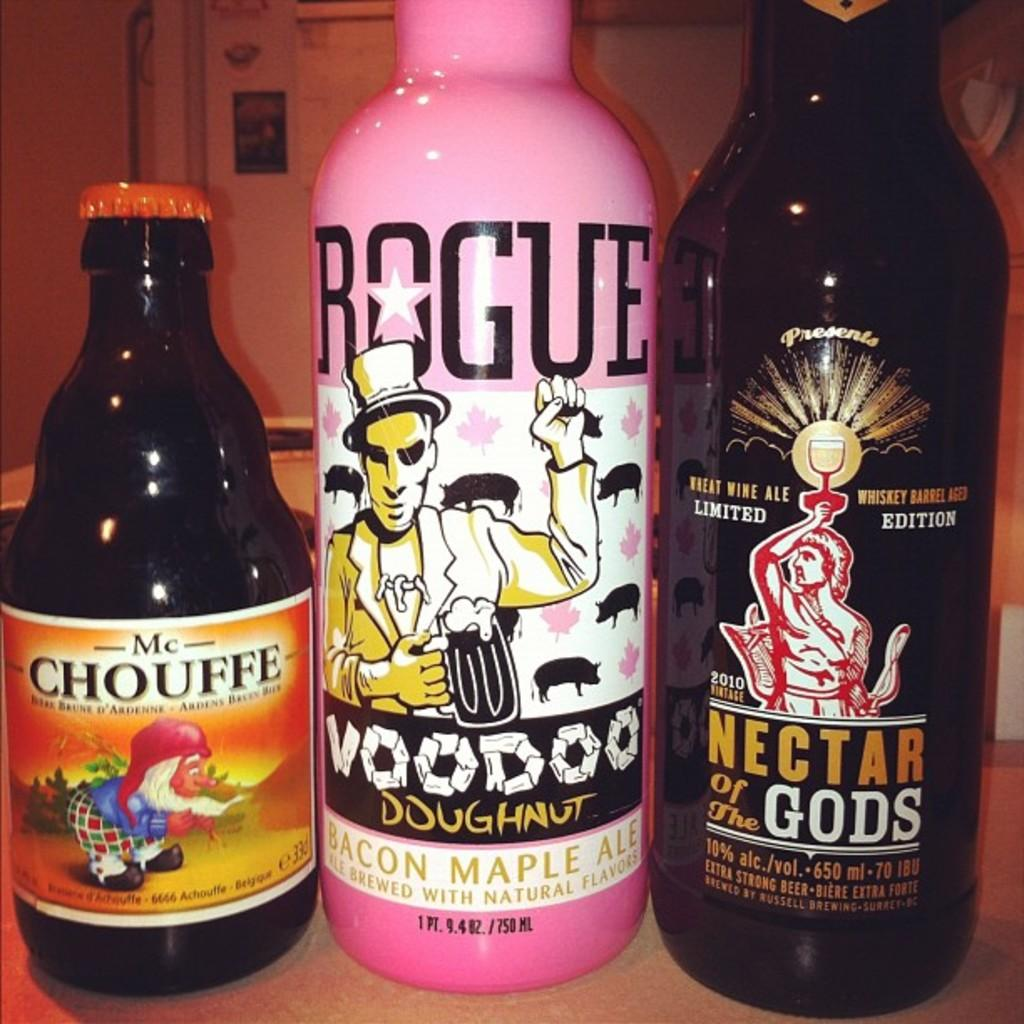<image>
Create a compact narrative representing the image presented. Several craft beers including a pink bottle of Voodoo Doughnut Bacon Maple Ale. 